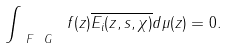<formula> <loc_0><loc_0><loc_500><loc_500>\int _ { \ F _ { \ } G } \ f ( z ) \overline { E _ { i } ( z , s , \chi ) } d \mu ( z ) = 0 .</formula> 